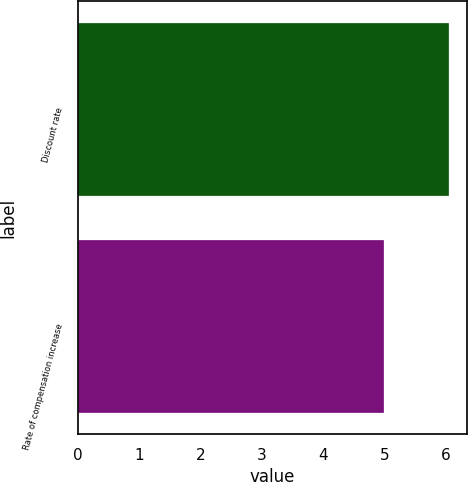Convert chart to OTSL. <chart><loc_0><loc_0><loc_500><loc_500><bar_chart><fcel>Discount rate<fcel>Rate of compensation increase<nl><fcel>6.05<fcel>5<nl></chart> 